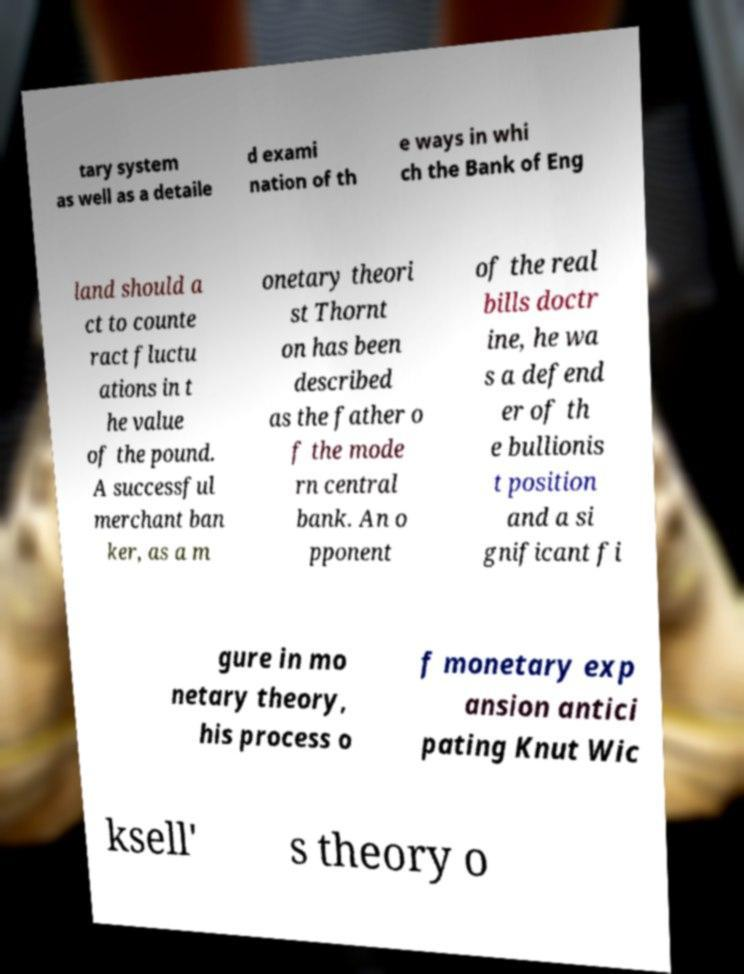What messages or text are displayed in this image? I need them in a readable, typed format. tary system as well as a detaile d exami nation of th e ways in whi ch the Bank of Eng land should a ct to counte ract fluctu ations in t he value of the pound. A successful merchant ban ker, as a m onetary theori st Thornt on has been described as the father o f the mode rn central bank. An o pponent of the real bills doctr ine, he wa s a defend er of th e bullionis t position and a si gnificant fi gure in mo netary theory, his process o f monetary exp ansion antici pating Knut Wic ksell' s theory o 